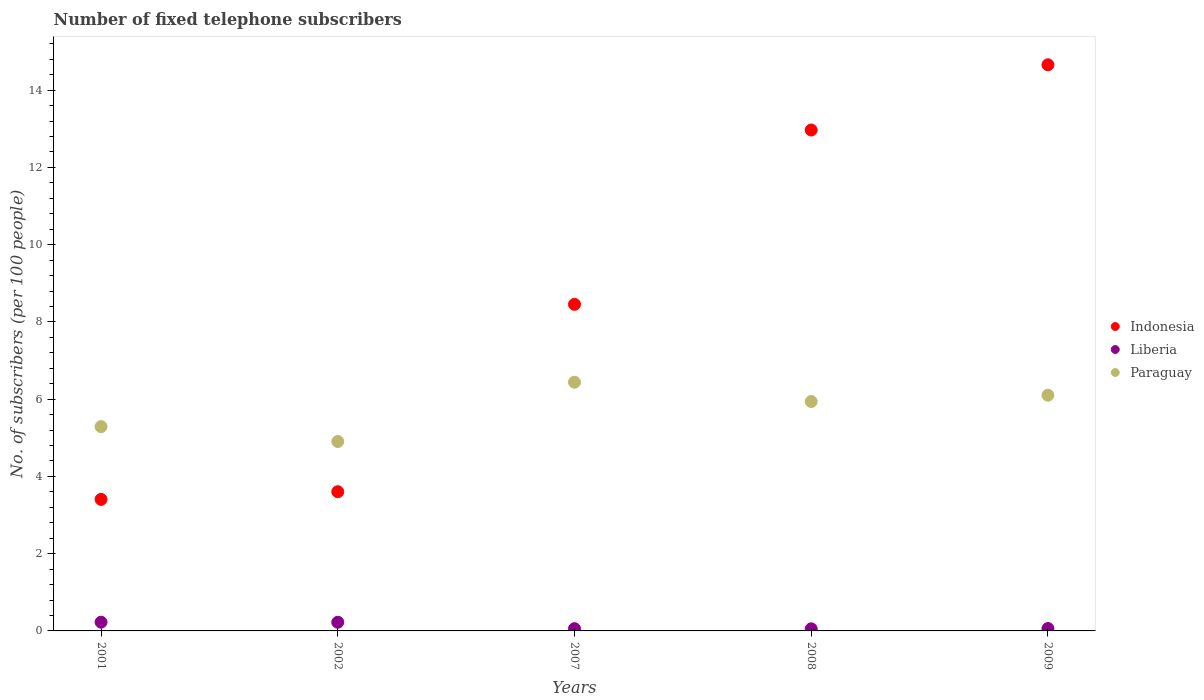What is the number of fixed telephone subscribers in Paraguay in 2008?
Keep it short and to the point. 5.94. Across all years, what is the maximum number of fixed telephone subscribers in Liberia?
Your answer should be compact. 0.23. Across all years, what is the minimum number of fixed telephone subscribers in Paraguay?
Your response must be concise. 4.9. In which year was the number of fixed telephone subscribers in Liberia maximum?
Ensure brevity in your answer.  2001. What is the total number of fixed telephone subscribers in Indonesia in the graph?
Your answer should be compact. 43.09. What is the difference between the number of fixed telephone subscribers in Indonesia in 2001 and that in 2009?
Your answer should be very brief. -11.25. What is the difference between the number of fixed telephone subscribers in Liberia in 2001 and the number of fixed telephone subscribers in Paraguay in 2007?
Make the answer very short. -6.21. What is the average number of fixed telephone subscribers in Paraguay per year?
Provide a short and direct response. 5.73. In the year 2007, what is the difference between the number of fixed telephone subscribers in Paraguay and number of fixed telephone subscribers in Liberia?
Give a very brief answer. 6.38. What is the ratio of the number of fixed telephone subscribers in Indonesia in 2007 to that in 2008?
Your answer should be very brief. 0.65. Is the number of fixed telephone subscribers in Paraguay in 2002 less than that in 2007?
Your answer should be compact. Yes. What is the difference between the highest and the second highest number of fixed telephone subscribers in Paraguay?
Make the answer very short. 0.34. What is the difference between the highest and the lowest number of fixed telephone subscribers in Liberia?
Your response must be concise. 0.17. Is the sum of the number of fixed telephone subscribers in Paraguay in 2002 and 2008 greater than the maximum number of fixed telephone subscribers in Liberia across all years?
Your answer should be compact. Yes. Does the number of fixed telephone subscribers in Liberia monotonically increase over the years?
Ensure brevity in your answer.  No. Is the number of fixed telephone subscribers in Indonesia strictly greater than the number of fixed telephone subscribers in Paraguay over the years?
Provide a short and direct response. No. Is the number of fixed telephone subscribers in Liberia strictly less than the number of fixed telephone subscribers in Indonesia over the years?
Keep it short and to the point. Yes. What is the difference between two consecutive major ticks on the Y-axis?
Your answer should be very brief. 2. Does the graph contain any zero values?
Give a very brief answer. No. Where does the legend appear in the graph?
Offer a terse response. Center right. What is the title of the graph?
Give a very brief answer. Number of fixed telephone subscribers. Does "Jamaica" appear as one of the legend labels in the graph?
Your answer should be very brief. No. What is the label or title of the X-axis?
Offer a terse response. Years. What is the label or title of the Y-axis?
Offer a very short reply. No. of subscribers (per 100 people). What is the No. of subscribers (per 100 people) of Indonesia in 2001?
Provide a short and direct response. 3.41. What is the No. of subscribers (per 100 people) of Liberia in 2001?
Give a very brief answer. 0.23. What is the No. of subscribers (per 100 people) in Paraguay in 2001?
Your answer should be compact. 5.29. What is the No. of subscribers (per 100 people) in Indonesia in 2002?
Ensure brevity in your answer.  3.6. What is the No. of subscribers (per 100 people) in Liberia in 2002?
Offer a very short reply. 0.22. What is the No. of subscribers (per 100 people) of Paraguay in 2002?
Provide a succinct answer. 4.9. What is the No. of subscribers (per 100 people) of Indonesia in 2007?
Offer a terse response. 8.46. What is the No. of subscribers (per 100 people) of Liberia in 2007?
Give a very brief answer. 0.06. What is the No. of subscribers (per 100 people) in Paraguay in 2007?
Your answer should be compact. 6.44. What is the No. of subscribers (per 100 people) of Indonesia in 2008?
Provide a succinct answer. 12.97. What is the No. of subscribers (per 100 people) in Liberia in 2008?
Your answer should be very brief. 0.05. What is the No. of subscribers (per 100 people) in Paraguay in 2008?
Offer a terse response. 5.94. What is the No. of subscribers (per 100 people) of Indonesia in 2009?
Your answer should be compact. 14.66. What is the No. of subscribers (per 100 people) in Liberia in 2009?
Provide a short and direct response. 0.06. What is the No. of subscribers (per 100 people) of Paraguay in 2009?
Keep it short and to the point. 6.1. Across all years, what is the maximum No. of subscribers (per 100 people) in Indonesia?
Offer a terse response. 14.66. Across all years, what is the maximum No. of subscribers (per 100 people) in Liberia?
Your answer should be compact. 0.23. Across all years, what is the maximum No. of subscribers (per 100 people) in Paraguay?
Provide a short and direct response. 6.44. Across all years, what is the minimum No. of subscribers (per 100 people) in Indonesia?
Keep it short and to the point. 3.41. Across all years, what is the minimum No. of subscribers (per 100 people) in Liberia?
Your response must be concise. 0.05. Across all years, what is the minimum No. of subscribers (per 100 people) of Paraguay?
Offer a very short reply. 4.9. What is the total No. of subscribers (per 100 people) of Indonesia in the graph?
Offer a very short reply. 43.09. What is the total No. of subscribers (per 100 people) of Liberia in the graph?
Your response must be concise. 0.63. What is the total No. of subscribers (per 100 people) in Paraguay in the graph?
Make the answer very short. 28.67. What is the difference between the No. of subscribers (per 100 people) in Indonesia in 2001 and that in 2002?
Provide a short and direct response. -0.2. What is the difference between the No. of subscribers (per 100 people) in Liberia in 2001 and that in 2002?
Your response must be concise. 0. What is the difference between the No. of subscribers (per 100 people) of Paraguay in 2001 and that in 2002?
Your answer should be very brief. 0.39. What is the difference between the No. of subscribers (per 100 people) of Indonesia in 2001 and that in 2007?
Provide a succinct answer. -5.05. What is the difference between the No. of subscribers (per 100 people) in Liberia in 2001 and that in 2007?
Make the answer very short. 0.17. What is the difference between the No. of subscribers (per 100 people) in Paraguay in 2001 and that in 2007?
Give a very brief answer. -1.15. What is the difference between the No. of subscribers (per 100 people) of Indonesia in 2001 and that in 2008?
Provide a short and direct response. -9.56. What is the difference between the No. of subscribers (per 100 people) of Liberia in 2001 and that in 2008?
Provide a succinct answer. 0.17. What is the difference between the No. of subscribers (per 100 people) in Paraguay in 2001 and that in 2008?
Make the answer very short. -0.65. What is the difference between the No. of subscribers (per 100 people) in Indonesia in 2001 and that in 2009?
Your answer should be compact. -11.25. What is the difference between the No. of subscribers (per 100 people) of Liberia in 2001 and that in 2009?
Your response must be concise. 0.16. What is the difference between the No. of subscribers (per 100 people) of Paraguay in 2001 and that in 2009?
Give a very brief answer. -0.81. What is the difference between the No. of subscribers (per 100 people) of Indonesia in 2002 and that in 2007?
Your answer should be compact. -4.85. What is the difference between the No. of subscribers (per 100 people) in Liberia in 2002 and that in 2007?
Provide a short and direct response. 0.17. What is the difference between the No. of subscribers (per 100 people) in Paraguay in 2002 and that in 2007?
Provide a succinct answer. -1.54. What is the difference between the No. of subscribers (per 100 people) of Indonesia in 2002 and that in 2008?
Offer a very short reply. -9.36. What is the difference between the No. of subscribers (per 100 people) of Liberia in 2002 and that in 2008?
Your response must be concise. 0.17. What is the difference between the No. of subscribers (per 100 people) of Paraguay in 2002 and that in 2008?
Ensure brevity in your answer.  -1.04. What is the difference between the No. of subscribers (per 100 people) in Indonesia in 2002 and that in 2009?
Your answer should be very brief. -11.05. What is the difference between the No. of subscribers (per 100 people) of Liberia in 2002 and that in 2009?
Ensure brevity in your answer.  0.16. What is the difference between the No. of subscribers (per 100 people) in Paraguay in 2002 and that in 2009?
Ensure brevity in your answer.  -1.2. What is the difference between the No. of subscribers (per 100 people) in Indonesia in 2007 and that in 2008?
Your answer should be compact. -4.51. What is the difference between the No. of subscribers (per 100 people) of Liberia in 2007 and that in 2008?
Your response must be concise. 0. What is the difference between the No. of subscribers (per 100 people) in Paraguay in 2007 and that in 2008?
Offer a very short reply. 0.5. What is the difference between the No. of subscribers (per 100 people) in Indonesia in 2007 and that in 2009?
Keep it short and to the point. -6.2. What is the difference between the No. of subscribers (per 100 people) in Liberia in 2007 and that in 2009?
Keep it short and to the point. -0. What is the difference between the No. of subscribers (per 100 people) in Paraguay in 2007 and that in 2009?
Keep it short and to the point. 0.34. What is the difference between the No. of subscribers (per 100 people) of Indonesia in 2008 and that in 2009?
Your response must be concise. -1.69. What is the difference between the No. of subscribers (per 100 people) in Liberia in 2008 and that in 2009?
Ensure brevity in your answer.  -0.01. What is the difference between the No. of subscribers (per 100 people) in Paraguay in 2008 and that in 2009?
Offer a terse response. -0.16. What is the difference between the No. of subscribers (per 100 people) of Indonesia in 2001 and the No. of subscribers (per 100 people) of Liberia in 2002?
Provide a succinct answer. 3.18. What is the difference between the No. of subscribers (per 100 people) in Indonesia in 2001 and the No. of subscribers (per 100 people) in Paraguay in 2002?
Provide a succinct answer. -1.5. What is the difference between the No. of subscribers (per 100 people) of Liberia in 2001 and the No. of subscribers (per 100 people) of Paraguay in 2002?
Make the answer very short. -4.68. What is the difference between the No. of subscribers (per 100 people) in Indonesia in 2001 and the No. of subscribers (per 100 people) in Liberia in 2007?
Give a very brief answer. 3.35. What is the difference between the No. of subscribers (per 100 people) in Indonesia in 2001 and the No. of subscribers (per 100 people) in Paraguay in 2007?
Provide a succinct answer. -3.03. What is the difference between the No. of subscribers (per 100 people) in Liberia in 2001 and the No. of subscribers (per 100 people) in Paraguay in 2007?
Your response must be concise. -6.21. What is the difference between the No. of subscribers (per 100 people) in Indonesia in 2001 and the No. of subscribers (per 100 people) in Liberia in 2008?
Offer a terse response. 3.35. What is the difference between the No. of subscribers (per 100 people) in Indonesia in 2001 and the No. of subscribers (per 100 people) in Paraguay in 2008?
Your response must be concise. -2.53. What is the difference between the No. of subscribers (per 100 people) in Liberia in 2001 and the No. of subscribers (per 100 people) in Paraguay in 2008?
Offer a terse response. -5.71. What is the difference between the No. of subscribers (per 100 people) in Indonesia in 2001 and the No. of subscribers (per 100 people) in Liberia in 2009?
Offer a very short reply. 3.34. What is the difference between the No. of subscribers (per 100 people) of Indonesia in 2001 and the No. of subscribers (per 100 people) of Paraguay in 2009?
Make the answer very short. -2.7. What is the difference between the No. of subscribers (per 100 people) of Liberia in 2001 and the No. of subscribers (per 100 people) of Paraguay in 2009?
Make the answer very short. -5.88. What is the difference between the No. of subscribers (per 100 people) of Indonesia in 2002 and the No. of subscribers (per 100 people) of Liberia in 2007?
Offer a terse response. 3.55. What is the difference between the No. of subscribers (per 100 people) of Indonesia in 2002 and the No. of subscribers (per 100 people) of Paraguay in 2007?
Offer a terse response. -2.84. What is the difference between the No. of subscribers (per 100 people) of Liberia in 2002 and the No. of subscribers (per 100 people) of Paraguay in 2007?
Offer a terse response. -6.21. What is the difference between the No. of subscribers (per 100 people) in Indonesia in 2002 and the No. of subscribers (per 100 people) in Liberia in 2008?
Ensure brevity in your answer.  3.55. What is the difference between the No. of subscribers (per 100 people) of Indonesia in 2002 and the No. of subscribers (per 100 people) of Paraguay in 2008?
Keep it short and to the point. -2.34. What is the difference between the No. of subscribers (per 100 people) of Liberia in 2002 and the No. of subscribers (per 100 people) of Paraguay in 2008?
Your answer should be very brief. -5.71. What is the difference between the No. of subscribers (per 100 people) of Indonesia in 2002 and the No. of subscribers (per 100 people) of Liberia in 2009?
Give a very brief answer. 3.54. What is the difference between the No. of subscribers (per 100 people) of Indonesia in 2002 and the No. of subscribers (per 100 people) of Paraguay in 2009?
Ensure brevity in your answer.  -2.5. What is the difference between the No. of subscribers (per 100 people) in Liberia in 2002 and the No. of subscribers (per 100 people) in Paraguay in 2009?
Your answer should be very brief. -5.88. What is the difference between the No. of subscribers (per 100 people) in Indonesia in 2007 and the No. of subscribers (per 100 people) in Liberia in 2008?
Your response must be concise. 8.4. What is the difference between the No. of subscribers (per 100 people) in Indonesia in 2007 and the No. of subscribers (per 100 people) in Paraguay in 2008?
Keep it short and to the point. 2.52. What is the difference between the No. of subscribers (per 100 people) in Liberia in 2007 and the No. of subscribers (per 100 people) in Paraguay in 2008?
Your answer should be very brief. -5.88. What is the difference between the No. of subscribers (per 100 people) of Indonesia in 2007 and the No. of subscribers (per 100 people) of Liberia in 2009?
Your response must be concise. 8.39. What is the difference between the No. of subscribers (per 100 people) of Indonesia in 2007 and the No. of subscribers (per 100 people) of Paraguay in 2009?
Your answer should be very brief. 2.35. What is the difference between the No. of subscribers (per 100 people) of Liberia in 2007 and the No. of subscribers (per 100 people) of Paraguay in 2009?
Offer a very short reply. -6.04. What is the difference between the No. of subscribers (per 100 people) of Indonesia in 2008 and the No. of subscribers (per 100 people) of Liberia in 2009?
Your response must be concise. 12.91. What is the difference between the No. of subscribers (per 100 people) in Indonesia in 2008 and the No. of subscribers (per 100 people) in Paraguay in 2009?
Provide a short and direct response. 6.87. What is the difference between the No. of subscribers (per 100 people) in Liberia in 2008 and the No. of subscribers (per 100 people) in Paraguay in 2009?
Make the answer very short. -6.05. What is the average No. of subscribers (per 100 people) in Indonesia per year?
Your answer should be very brief. 8.62. What is the average No. of subscribers (per 100 people) of Liberia per year?
Make the answer very short. 0.13. What is the average No. of subscribers (per 100 people) of Paraguay per year?
Keep it short and to the point. 5.73. In the year 2001, what is the difference between the No. of subscribers (per 100 people) of Indonesia and No. of subscribers (per 100 people) of Liberia?
Ensure brevity in your answer.  3.18. In the year 2001, what is the difference between the No. of subscribers (per 100 people) in Indonesia and No. of subscribers (per 100 people) in Paraguay?
Your answer should be compact. -1.88. In the year 2001, what is the difference between the No. of subscribers (per 100 people) of Liberia and No. of subscribers (per 100 people) of Paraguay?
Provide a short and direct response. -5.06. In the year 2002, what is the difference between the No. of subscribers (per 100 people) in Indonesia and No. of subscribers (per 100 people) in Liberia?
Give a very brief answer. 3.38. In the year 2002, what is the difference between the No. of subscribers (per 100 people) of Indonesia and No. of subscribers (per 100 people) of Paraguay?
Provide a succinct answer. -1.3. In the year 2002, what is the difference between the No. of subscribers (per 100 people) of Liberia and No. of subscribers (per 100 people) of Paraguay?
Your response must be concise. -4.68. In the year 2007, what is the difference between the No. of subscribers (per 100 people) in Indonesia and No. of subscribers (per 100 people) in Liberia?
Offer a terse response. 8.4. In the year 2007, what is the difference between the No. of subscribers (per 100 people) in Indonesia and No. of subscribers (per 100 people) in Paraguay?
Give a very brief answer. 2.02. In the year 2007, what is the difference between the No. of subscribers (per 100 people) in Liberia and No. of subscribers (per 100 people) in Paraguay?
Your response must be concise. -6.38. In the year 2008, what is the difference between the No. of subscribers (per 100 people) in Indonesia and No. of subscribers (per 100 people) in Liberia?
Ensure brevity in your answer.  12.91. In the year 2008, what is the difference between the No. of subscribers (per 100 people) of Indonesia and No. of subscribers (per 100 people) of Paraguay?
Offer a terse response. 7.03. In the year 2008, what is the difference between the No. of subscribers (per 100 people) in Liberia and No. of subscribers (per 100 people) in Paraguay?
Provide a short and direct response. -5.88. In the year 2009, what is the difference between the No. of subscribers (per 100 people) of Indonesia and No. of subscribers (per 100 people) of Liberia?
Keep it short and to the point. 14.6. In the year 2009, what is the difference between the No. of subscribers (per 100 people) of Indonesia and No. of subscribers (per 100 people) of Paraguay?
Give a very brief answer. 8.56. In the year 2009, what is the difference between the No. of subscribers (per 100 people) in Liberia and No. of subscribers (per 100 people) in Paraguay?
Ensure brevity in your answer.  -6.04. What is the ratio of the No. of subscribers (per 100 people) of Indonesia in 2001 to that in 2002?
Ensure brevity in your answer.  0.94. What is the ratio of the No. of subscribers (per 100 people) of Liberia in 2001 to that in 2002?
Ensure brevity in your answer.  1.01. What is the ratio of the No. of subscribers (per 100 people) in Paraguay in 2001 to that in 2002?
Your response must be concise. 1.08. What is the ratio of the No. of subscribers (per 100 people) of Indonesia in 2001 to that in 2007?
Provide a short and direct response. 0.4. What is the ratio of the No. of subscribers (per 100 people) of Liberia in 2001 to that in 2007?
Your response must be concise. 3.9. What is the ratio of the No. of subscribers (per 100 people) in Paraguay in 2001 to that in 2007?
Give a very brief answer. 0.82. What is the ratio of the No. of subscribers (per 100 people) in Indonesia in 2001 to that in 2008?
Make the answer very short. 0.26. What is the ratio of the No. of subscribers (per 100 people) in Liberia in 2001 to that in 2008?
Give a very brief answer. 4.16. What is the ratio of the No. of subscribers (per 100 people) in Paraguay in 2001 to that in 2008?
Offer a terse response. 0.89. What is the ratio of the No. of subscribers (per 100 people) of Indonesia in 2001 to that in 2009?
Offer a terse response. 0.23. What is the ratio of the No. of subscribers (per 100 people) in Liberia in 2001 to that in 2009?
Your response must be concise. 3.65. What is the ratio of the No. of subscribers (per 100 people) of Paraguay in 2001 to that in 2009?
Provide a succinct answer. 0.87. What is the ratio of the No. of subscribers (per 100 people) in Indonesia in 2002 to that in 2007?
Make the answer very short. 0.43. What is the ratio of the No. of subscribers (per 100 people) of Liberia in 2002 to that in 2007?
Your response must be concise. 3.86. What is the ratio of the No. of subscribers (per 100 people) in Paraguay in 2002 to that in 2007?
Provide a short and direct response. 0.76. What is the ratio of the No. of subscribers (per 100 people) in Indonesia in 2002 to that in 2008?
Give a very brief answer. 0.28. What is the ratio of the No. of subscribers (per 100 people) in Liberia in 2002 to that in 2008?
Offer a terse response. 4.13. What is the ratio of the No. of subscribers (per 100 people) of Paraguay in 2002 to that in 2008?
Your response must be concise. 0.83. What is the ratio of the No. of subscribers (per 100 people) in Indonesia in 2002 to that in 2009?
Your response must be concise. 0.25. What is the ratio of the No. of subscribers (per 100 people) of Liberia in 2002 to that in 2009?
Keep it short and to the point. 3.62. What is the ratio of the No. of subscribers (per 100 people) of Paraguay in 2002 to that in 2009?
Make the answer very short. 0.8. What is the ratio of the No. of subscribers (per 100 people) in Indonesia in 2007 to that in 2008?
Provide a succinct answer. 0.65. What is the ratio of the No. of subscribers (per 100 people) in Liberia in 2007 to that in 2008?
Provide a short and direct response. 1.07. What is the ratio of the No. of subscribers (per 100 people) of Paraguay in 2007 to that in 2008?
Give a very brief answer. 1.08. What is the ratio of the No. of subscribers (per 100 people) in Indonesia in 2007 to that in 2009?
Make the answer very short. 0.58. What is the ratio of the No. of subscribers (per 100 people) of Liberia in 2007 to that in 2009?
Keep it short and to the point. 0.94. What is the ratio of the No. of subscribers (per 100 people) in Paraguay in 2007 to that in 2009?
Your answer should be compact. 1.06. What is the ratio of the No. of subscribers (per 100 people) in Indonesia in 2008 to that in 2009?
Keep it short and to the point. 0.88. What is the ratio of the No. of subscribers (per 100 people) in Liberia in 2008 to that in 2009?
Provide a succinct answer. 0.88. What is the ratio of the No. of subscribers (per 100 people) in Paraguay in 2008 to that in 2009?
Your answer should be very brief. 0.97. What is the difference between the highest and the second highest No. of subscribers (per 100 people) of Indonesia?
Provide a short and direct response. 1.69. What is the difference between the highest and the second highest No. of subscribers (per 100 people) in Liberia?
Offer a very short reply. 0. What is the difference between the highest and the second highest No. of subscribers (per 100 people) of Paraguay?
Make the answer very short. 0.34. What is the difference between the highest and the lowest No. of subscribers (per 100 people) in Indonesia?
Your answer should be compact. 11.25. What is the difference between the highest and the lowest No. of subscribers (per 100 people) of Liberia?
Keep it short and to the point. 0.17. What is the difference between the highest and the lowest No. of subscribers (per 100 people) of Paraguay?
Make the answer very short. 1.54. 